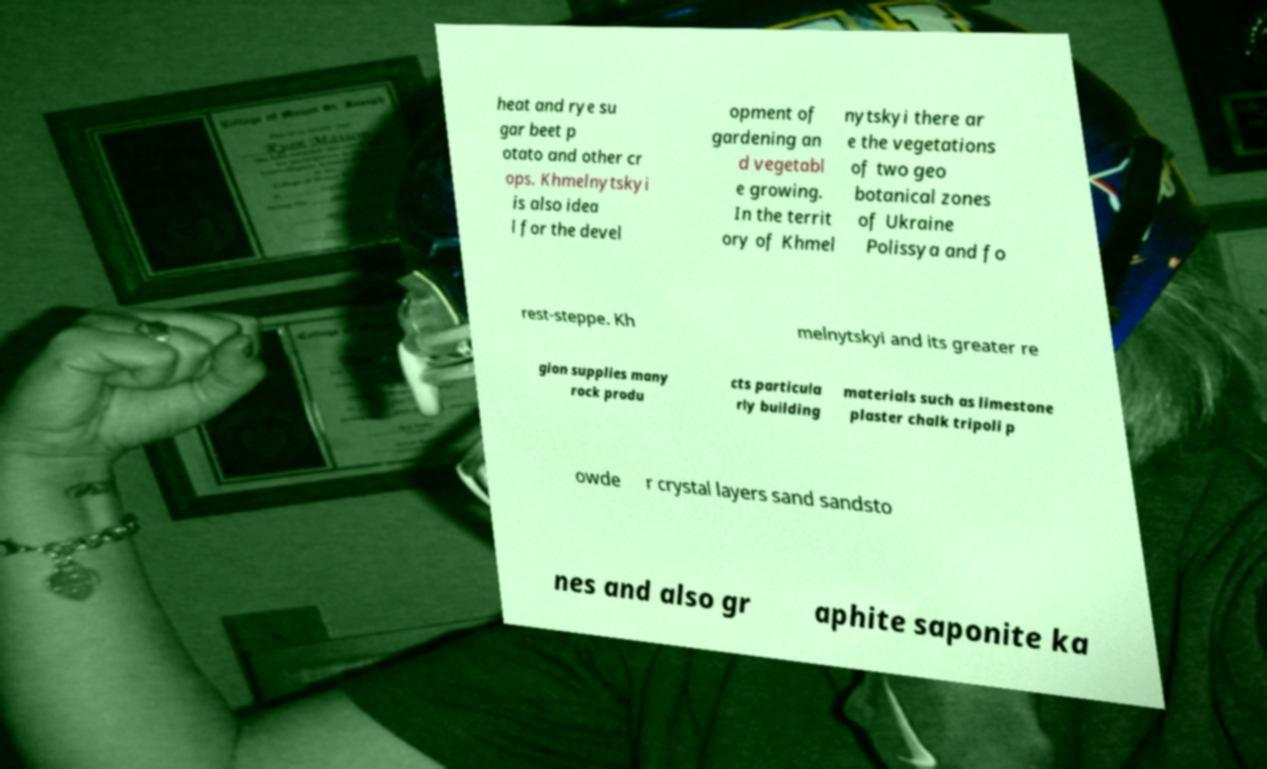Can you accurately transcribe the text from the provided image for me? heat and rye su gar beet p otato and other cr ops. Khmelnytskyi is also idea l for the devel opment of gardening an d vegetabl e growing. In the territ ory of Khmel nytskyi there ar e the vegetations of two geo botanical zones of Ukraine Polissya and fo rest-steppe. Kh melnytskyi and its greater re gion supplies many rock produ cts particula rly building materials such as limestone plaster chalk tripoli p owde r crystal layers sand sandsto nes and also gr aphite saponite ka 